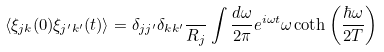Convert formula to latex. <formula><loc_0><loc_0><loc_500><loc_500>\langle \xi _ { j k } ( 0 ) \xi _ { j ^ { \prime } k ^ { \prime } } ( t ) \rangle = \delta _ { j j ^ { \prime } } \delta _ { k k ^ { \prime } } \frac { } { R _ { j } } \int \frac { d \omega } { 2 \pi } e ^ { i \omega t } \omega \coth \left ( \frac { \hbar { \omega } } { 2 T } \right )</formula> 